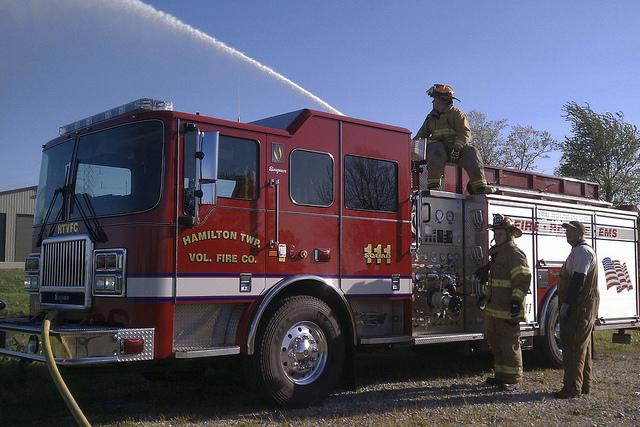What province does this fire crew reside in? hamilton 